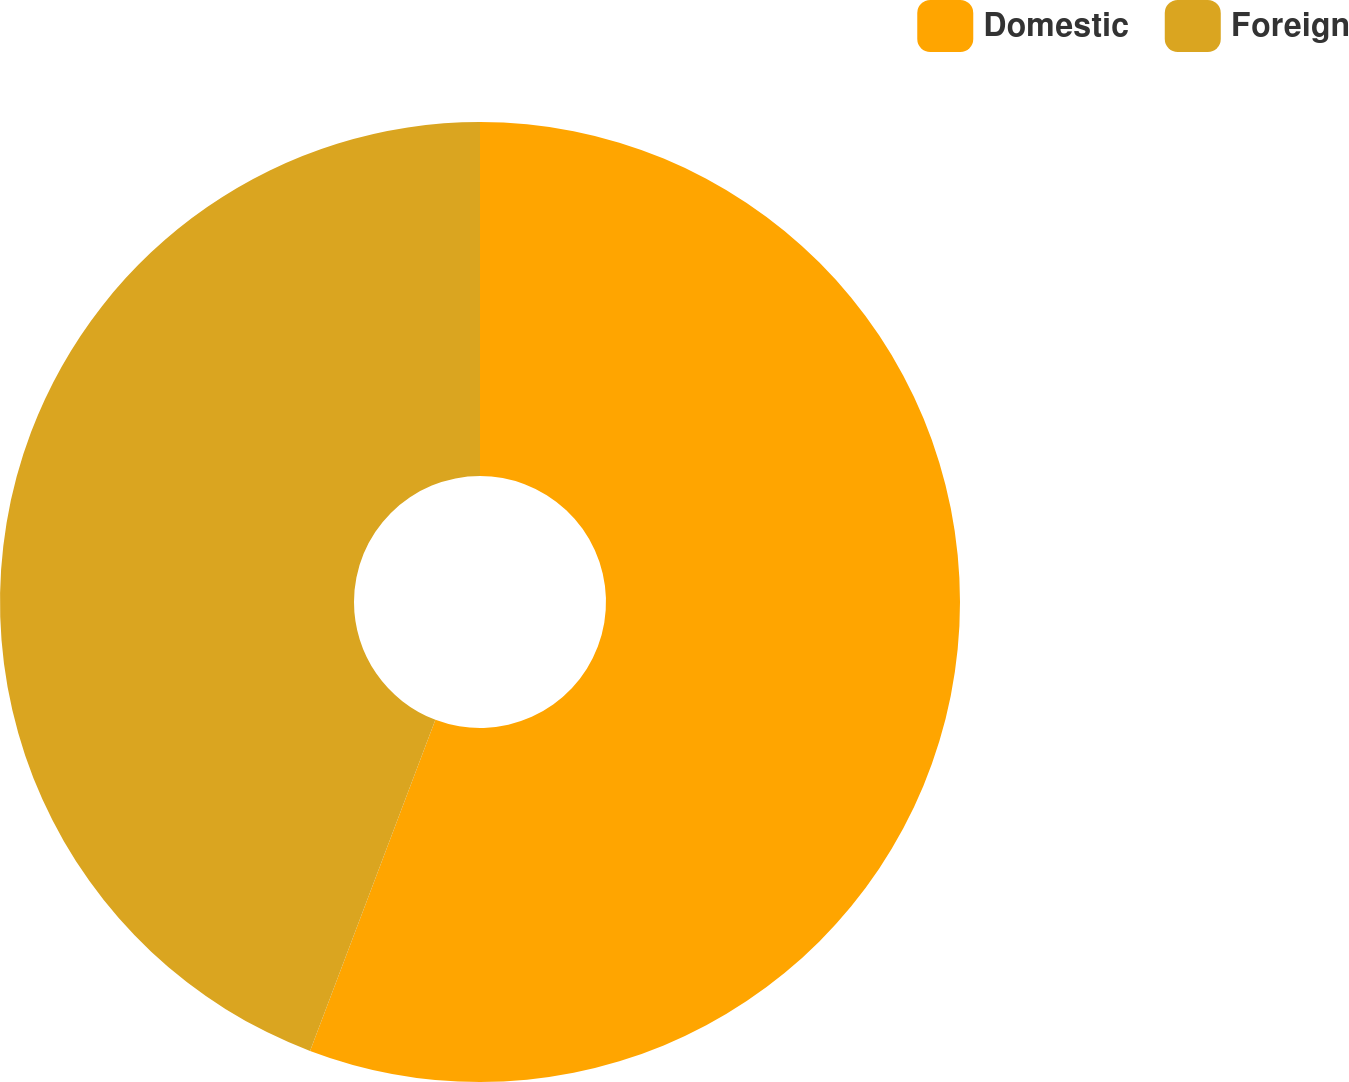<chart> <loc_0><loc_0><loc_500><loc_500><pie_chart><fcel>Domestic<fcel>Foreign<nl><fcel>55.76%<fcel>44.24%<nl></chart> 